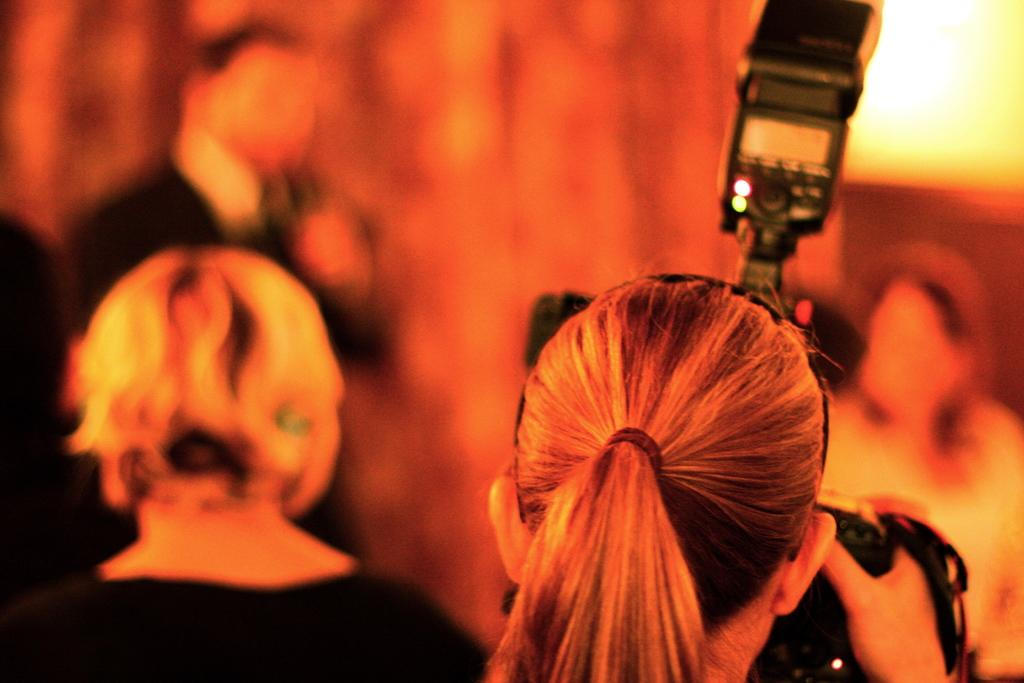What is happening in the image? There are people standing in the image. Can you identify any specific actions being performed by the people? One person is holding a camera. What can be observed about the background of the image? The background of the image is blurred. How many toes can be seen on the people in the image? There is no information provided about the number of toes visible in the image. 